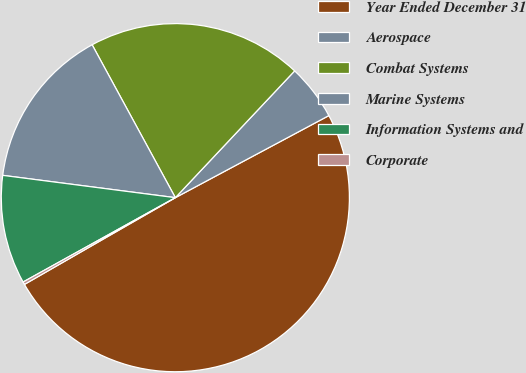<chart> <loc_0><loc_0><loc_500><loc_500><pie_chart><fcel>Year Ended December 31<fcel>Aerospace<fcel>Combat Systems<fcel>Marine Systems<fcel>Information Systems and<fcel>Corporate<nl><fcel>49.51%<fcel>5.17%<fcel>19.95%<fcel>15.02%<fcel>10.1%<fcel>0.25%<nl></chart> 